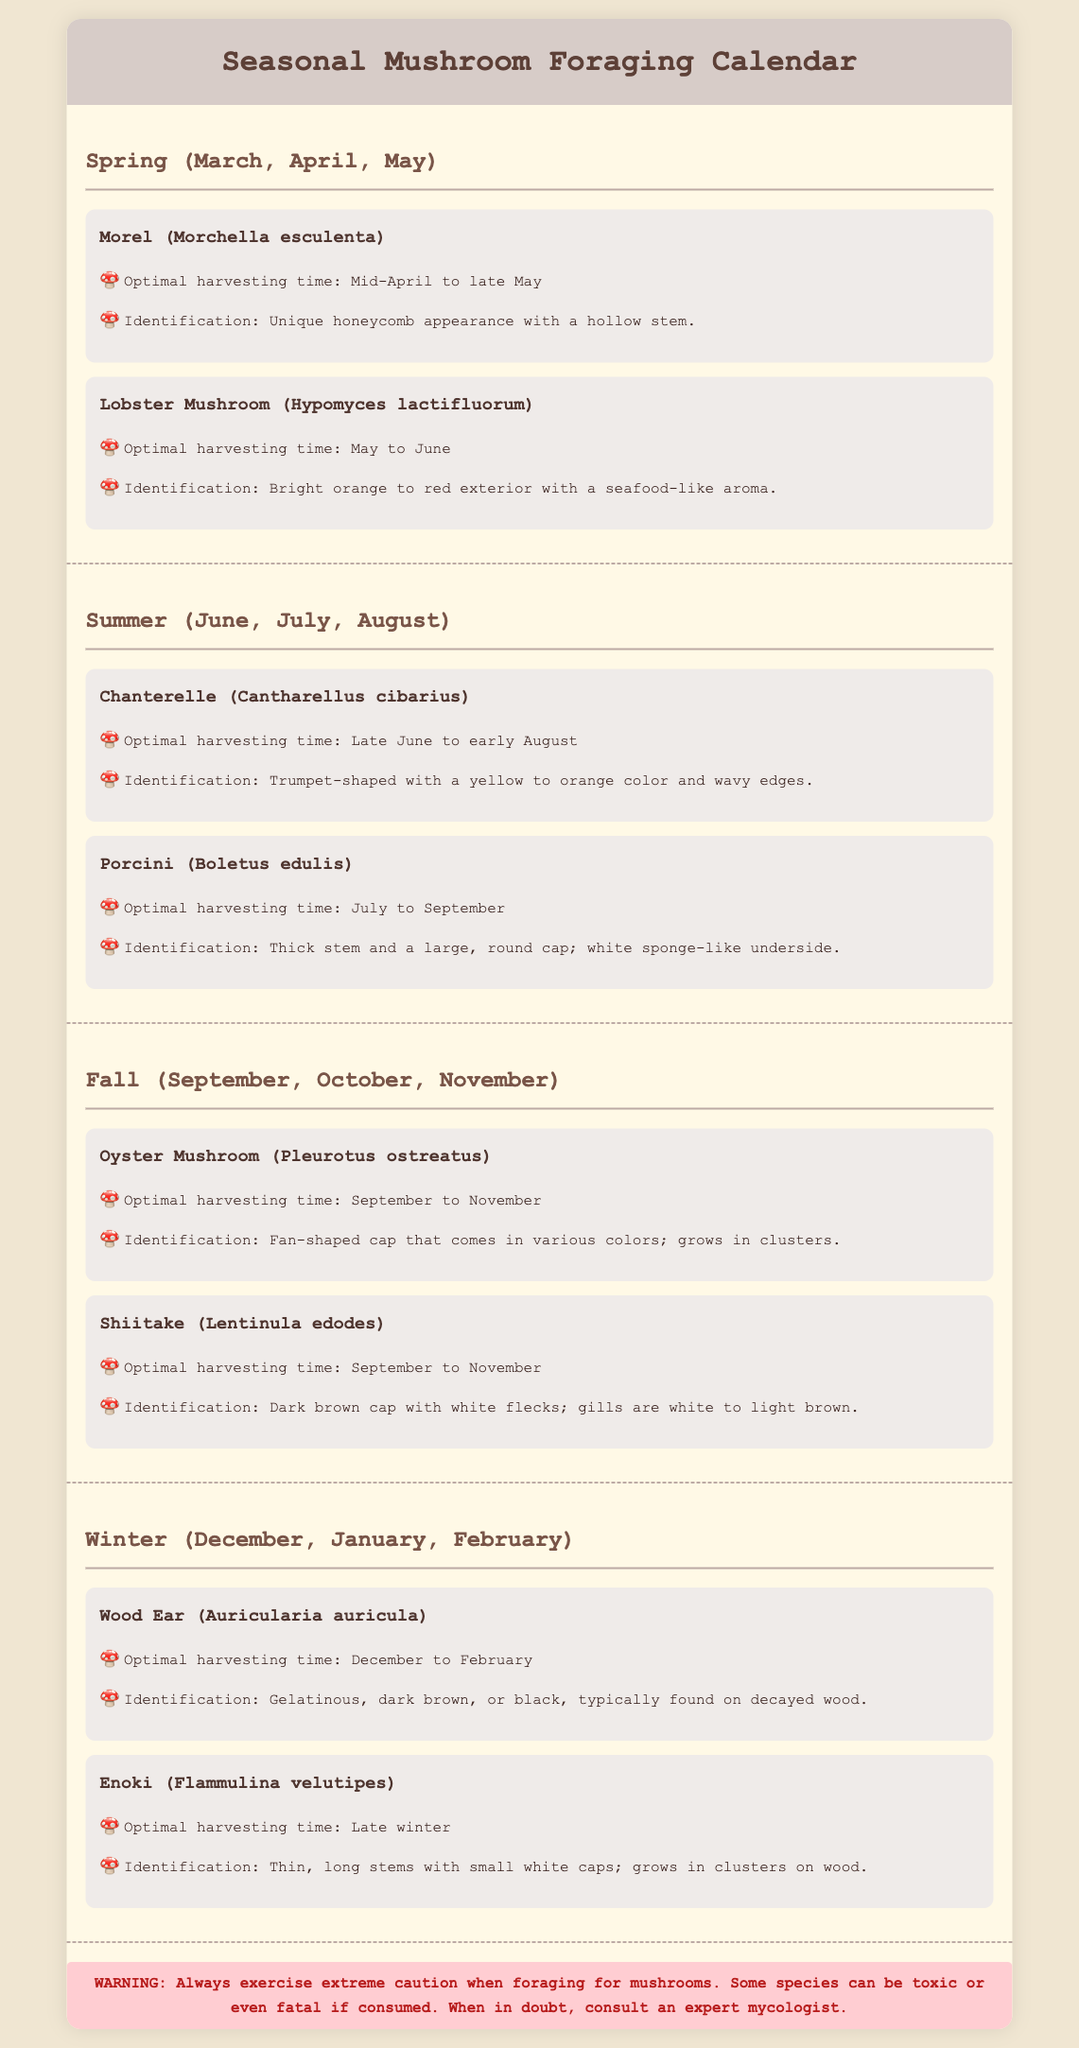What is the optimal harvesting time for Morel? The document states that the optimal harvesting time for Morel is from mid-April to late May.
Answer: Mid-April to late May What mushroom is harvested in July to September? According to the document, the Porcini mushroom is harvested during that time.
Answer: Porcini What is the identification feature of the Chanterelle? The document mentions that Chanterelles are trumpet-shaped with a yellow to orange color and wavy edges.
Answer: Trumpet-shaped, yellow to orange color, wavy edges During which season can you find the Wood Ear mushroom? The document explains that Wood Ear mushrooms are found in winter, specifically from December to February.
Answer: Winter What is the identification feature of the Shiitake? The document describes Shiitake mushrooms as having a dark brown cap with white flecks and white to light brown gills.
Answer: Dark brown cap with white flecks Which mushroom is known for its bright orange to red exterior? The document indicates that the Lobster Mushroom is known for its bright orange to red exterior.
Answer: Lobster Mushroom How many mushrooms are listed for the Fall season? The document lists two mushrooms for the Fall season: Oyster and Shiitake.
Answer: Two What is the warning provided in the document? The document includes a warning advising caution when foraging for mushrooms due to potential toxicity.
Answer: Always exercise extreme caution when foraging for mushrooms 